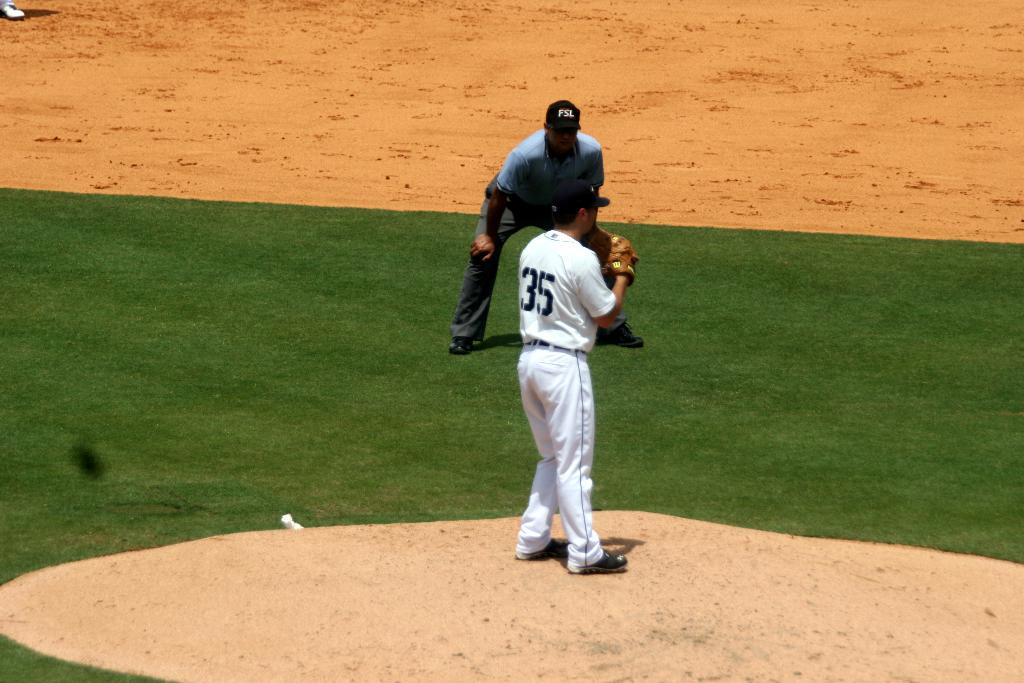<image>
Relay a brief, clear account of the picture shown. Umpire with hands on his knees and FSL on his ball cap. 